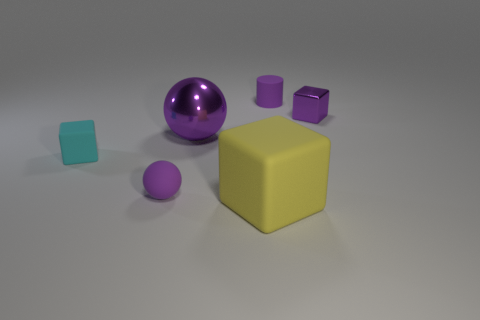There is a shiny object that is left of the tiny matte thing that is right of the big metal ball; what is its color?
Provide a succinct answer. Purple. There is a cyan cube that is the same size as the purple matte cylinder; what is its material?
Offer a terse response. Rubber. What number of rubber objects are big purple things or large cyan cylinders?
Keep it short and to the point. 0. What color is the block that is to the right of the purple matte ball and left of the tiny metal thing?
Ensure brevity in your answer.  Yellow. What number of tiny matte objects are behind the tiny metal block?
Provide a succinct answer. 1. What is the material of the big purple ball?
Keep it short and to the point. Metal. What is the color of the small cube that is in front of the metallic object to the right of the tiny purple matte thing behind the purple cube?
Provide a short and direct response. Cyan. How many purple rubber balls are the same size as the purple block?
Make the answer very short. 1. What color is the small block left of the purple cylinder?
Your answer should be very brief. Cyan. How many other things are there of the same size as the metal ball?
Provide a short and direct response. 1. 